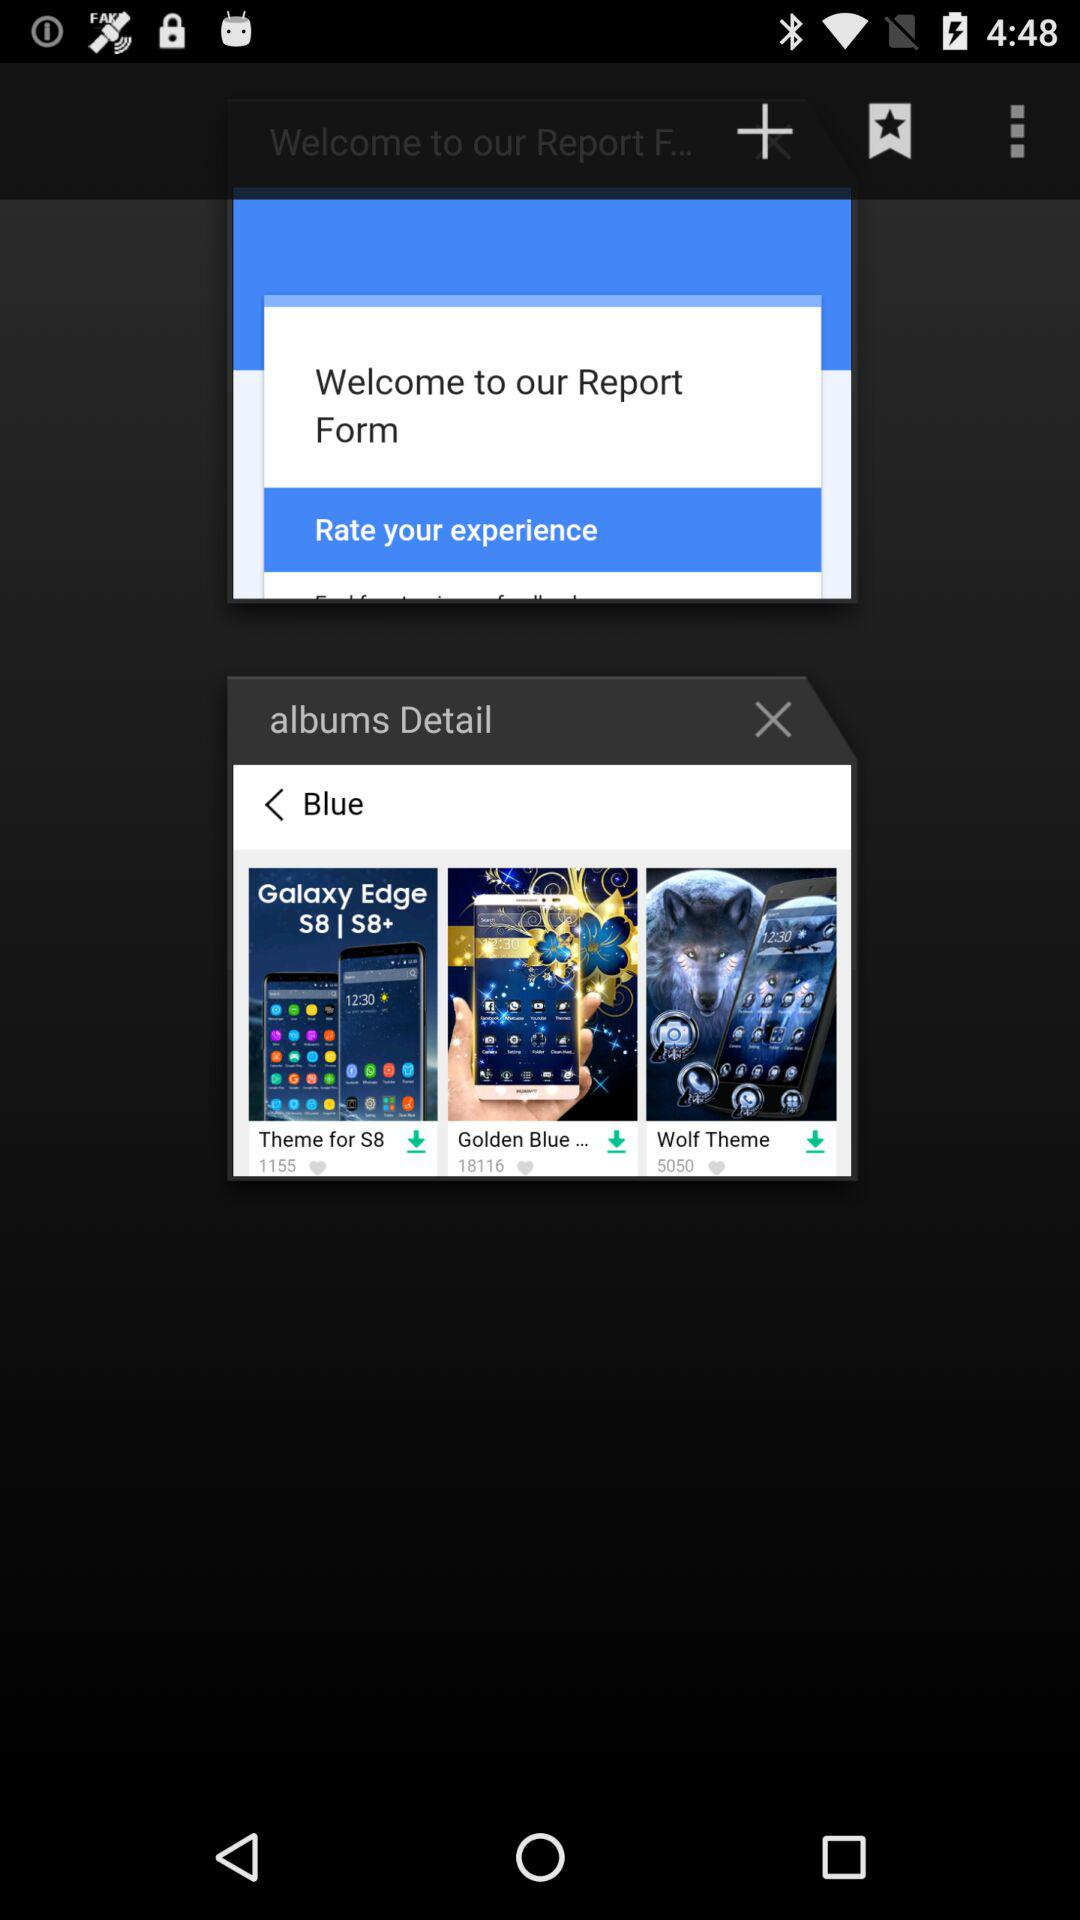How many likes does the Wolf theme get? The Wolf theme got 5050 likes. 